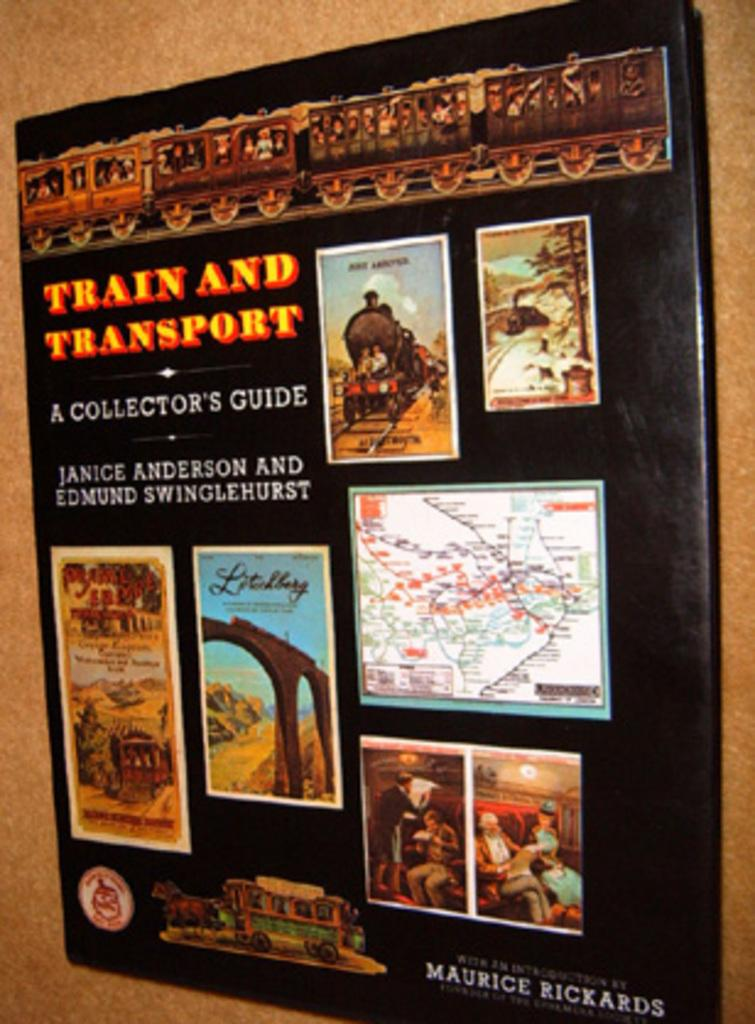<image>
Write a terse but informative summary of the picture. a sign giving the history of train and transport 